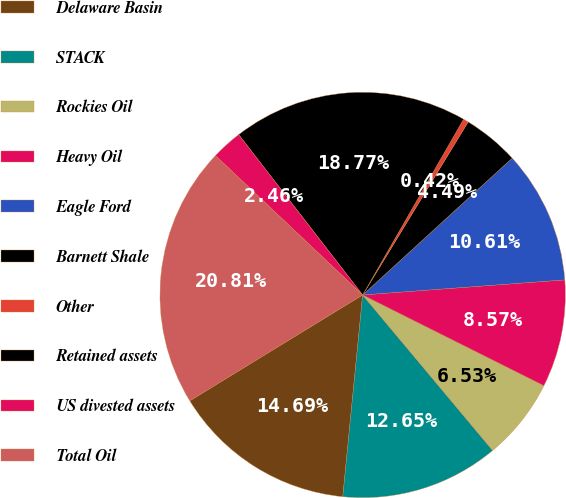Convert chart. <chart><loc_0><loc_0><loc_500><loc_500><pie_chart><fcel>Delaware Basin<fcel>STACK<fcel>Rockies Oil<fcel>Heavy Oil<fcel>Eagle Ford<fcel>Barnett Shale<fcel>Other<fcel>Retained assets<fcel>US divested assets<fcel>Total Oil<nl><fcel>14.69%<fcel>12.65%<fcel>6.53%<fcel>8.57%<fcel>10.61%<fcel>4.49%<fcel>0.42%<fcel>18.77%<fcel>2.46%<fcel>20.81%<nl></chart> 